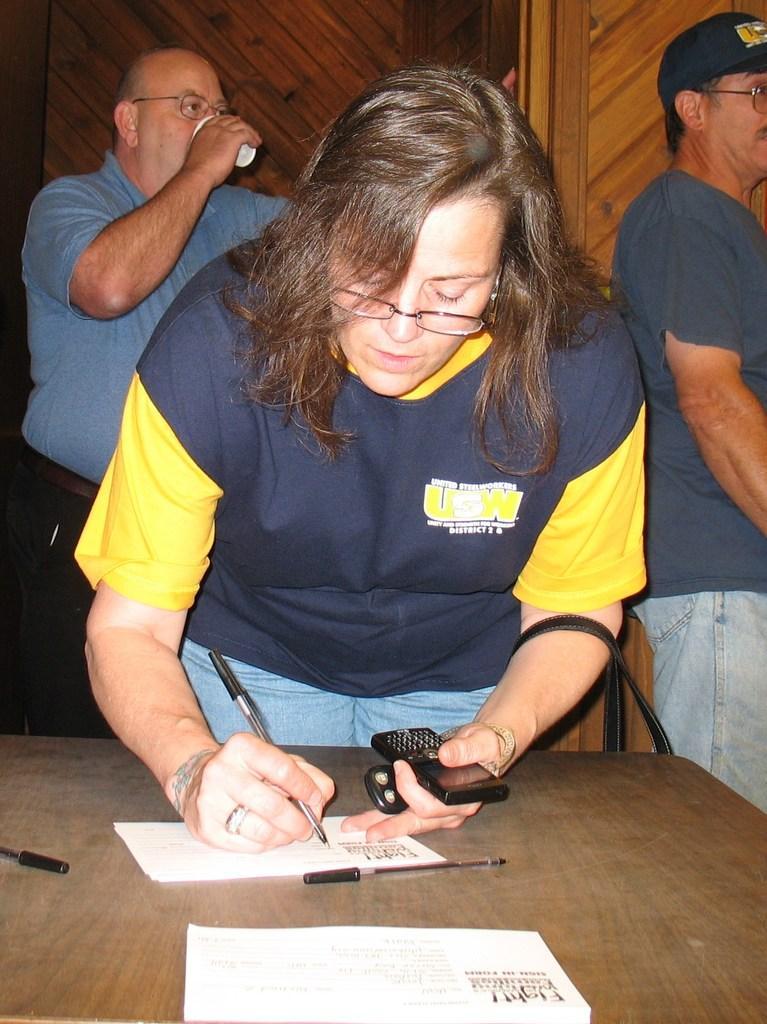Could you give a brief overview of what you see in this image? In this image we can see there is a woman writing something on the paper. There are pens on the table. There are people. 